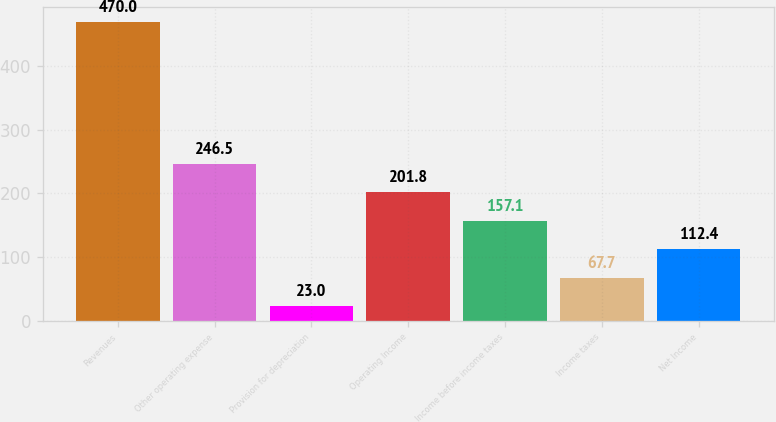<chart> <loc_0><loc_0><loc_500><loc_500><bar_chart><fcel>Revenues<fcel>Other operating expense<fcel>Provision for depreciation<fcel>Operating Income<fcel>Income before income taxes<fcel>Income taxes<fcel>Net Income<nl><fcel>470<fcel>246.5<fcel>23<fcel>201.8<fcel>157.1<fcel>67.7<fcel>112.4<nl></chart> 